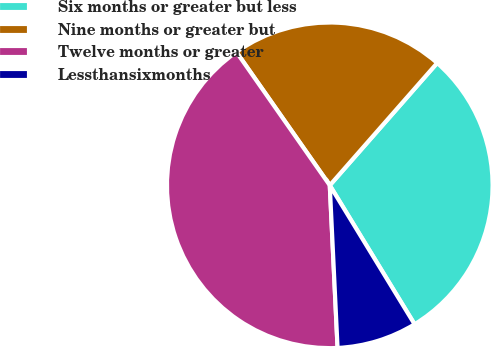<chart> <loc_0><loc_0><loc_500><loc_500><pie_chart><fcel>Six months or greater but less<fcel>Nine months or greater but<fcel>Twelve months or greater<fcel>Lessthansixmonths<nl><fcel>29.81%<fcel>21.19%<fcel>41.04%<fcel>7.96%<nl></chart> 